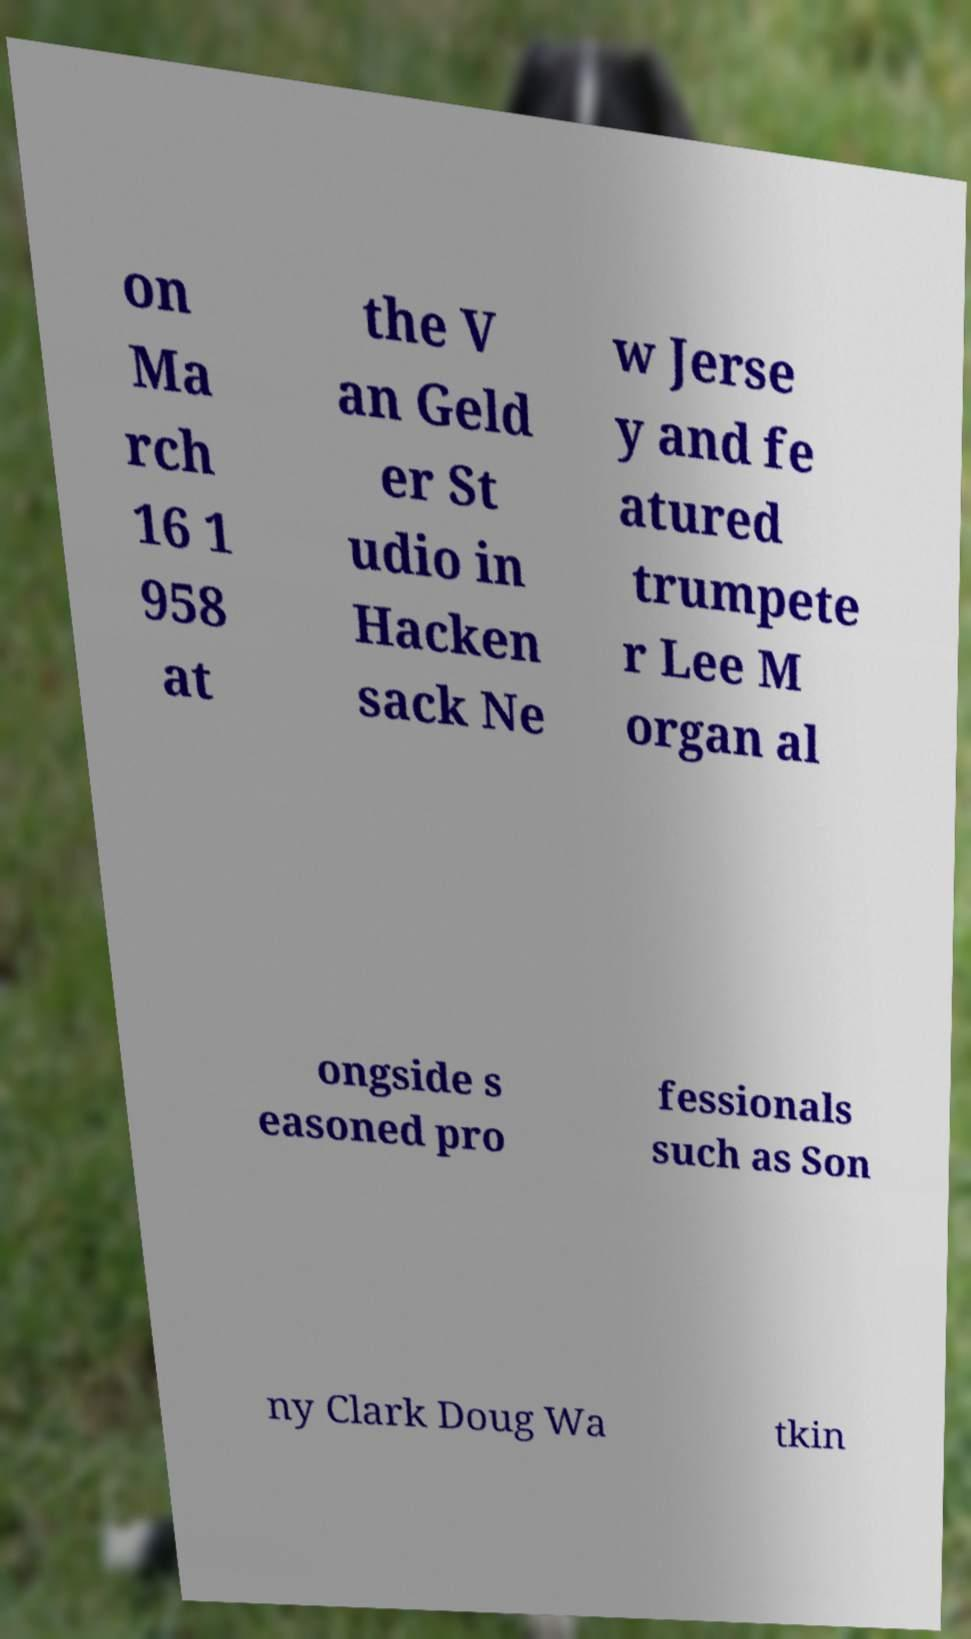I need the written content from this picture converted into text. Can you do that? on Ma rch 16 1 958 at the V an Geld er St udio in Hacken sack Ne w Jerse y and fe atured trumpete r Lee M organ al ongside s easoned pro fessionals such as Son ny Clark Doug Wa tkin 